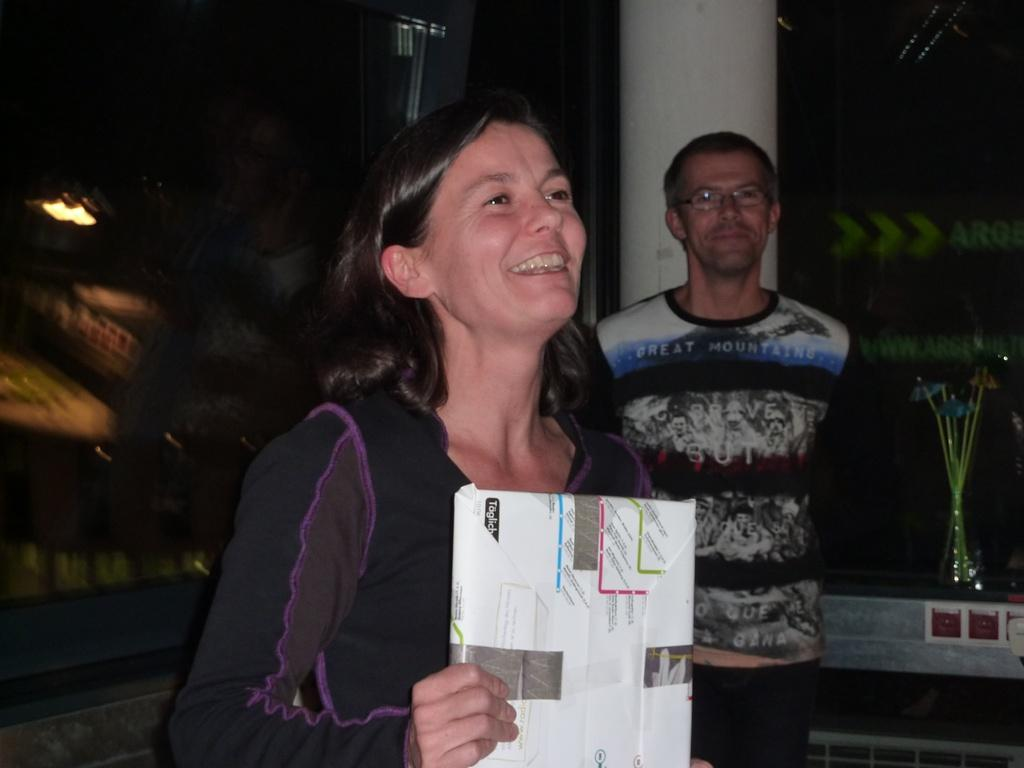What is the woman doing in the image? The woman is standing and smiling in the image. What is the woman holding in her hand? The woman is holding an object in her hand. Can you describe the man's position in relation to the woman? The man is standing at the back of the woman. What architectural feature can be seen in the image? There is a pillar in the image. What can be used to provide illumination in the image? There is a light in the image. How many eggs are being served by the servant in the image? There is no servant or eggs present in the image. What type of basin is visible in the image? There is no basin present in the image. 